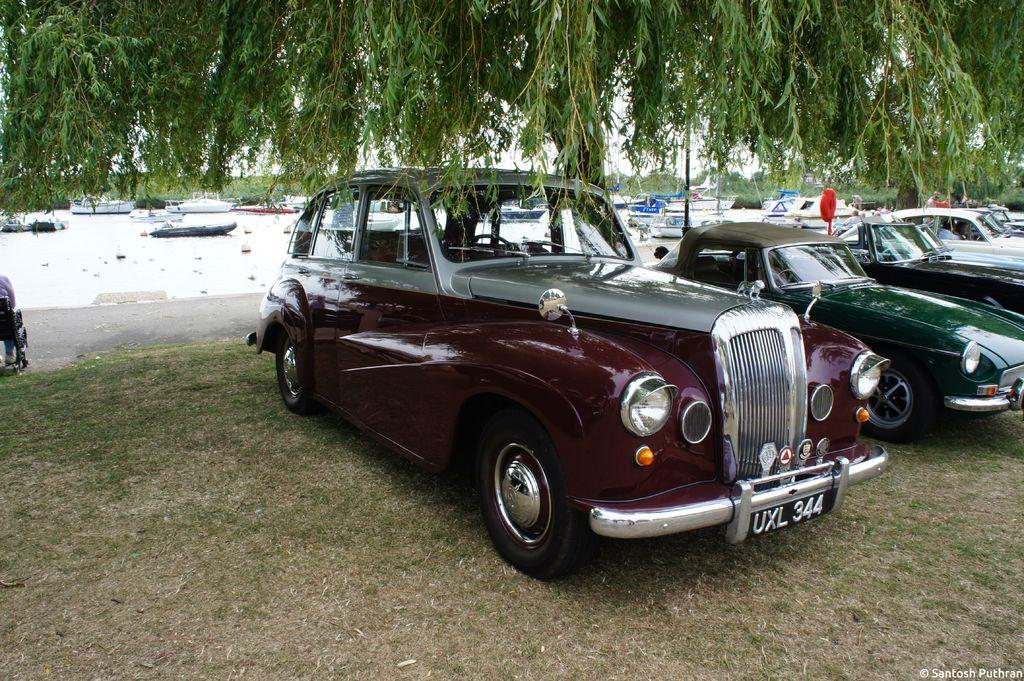What type of vegetation can be seen in the image? There are trees in the image. What else is present on the ground in the image? There are vehicles visible on the ground in the image. What can be seen in the background of the image? There are boats and water visible in the background of the image. How many oranges are hanging from the trees in the image? There are no oranges present in the image; it features trees, vehicles, boats, and water. Can you describe the tomatoes growing on the boats in the image? There are no tomatoes present in the image; it features trees, vehicles, boats, and water. 